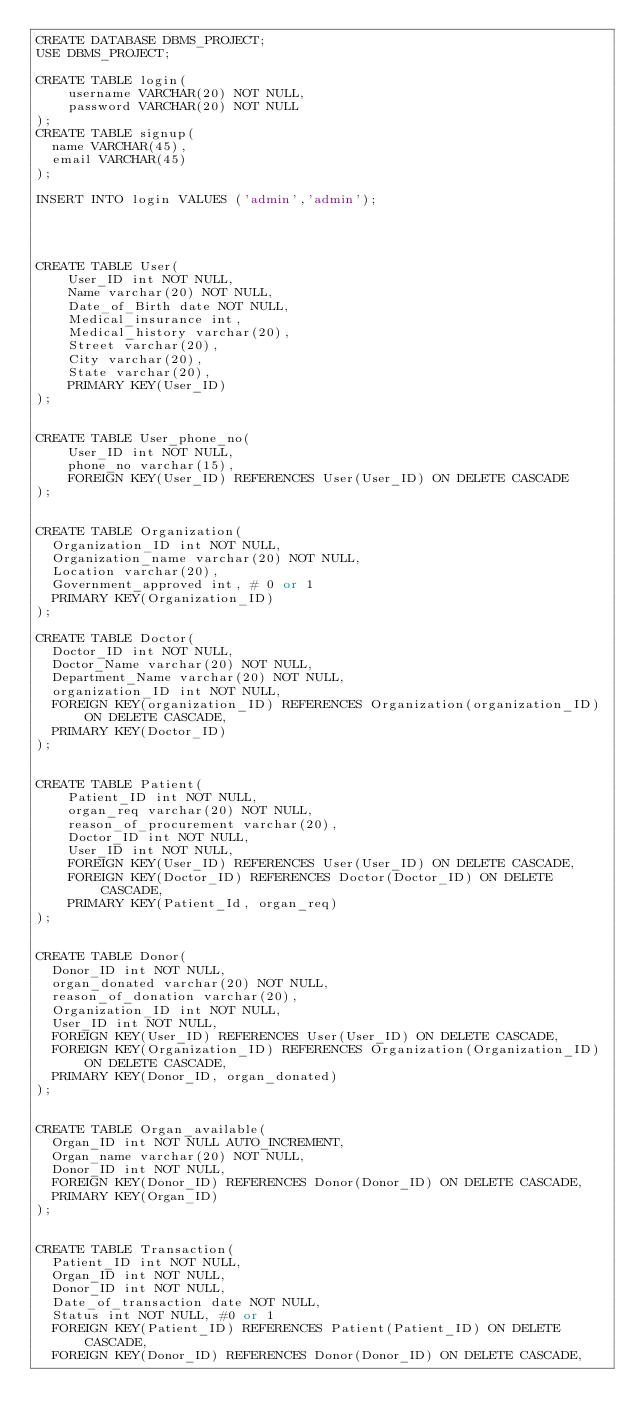Convert code to text. <code><loc_0><loc_0><loc_500><loc_500><_SQL_>CREATE DATABASE DBMS_PROJECT;
USE DBMS_PROJECT;

CREATE TABLE login(
    username VARCHAR(20) NOT NULL,
    password VARCHAR(20) NOT NULL
);
CREATE TABLE signup(
  name VARCHAR(45),
  email VARCHAR(45)
);

INSERT INTO login VALUES ('admin','admin');




CREATE TABLE User(
    User_ID int NOT NULL,
    Name varchar(20) NOT NULL,
    Date_of_Birth date NOT NULL,
    Medical_insurance int,
    Medical_history varchar(20),
    Street varchar(20),
    City varchar(20),
    State varchar(20),
    PRIMARY KEY(User_ID)
);


CREATE TABLE User_phone_no(
    User_ID int NOT NULL,
    phone_no varchar(15),
    FOREIGN KEY(User_ID) REFERENCES User(User_ID) ON DELETE CASCADE
);


CREATE TABLE Organization(
  Organization_ID int NOT NULL,
  Organization_name varchar(20) NOT NULL,
  Location varchar(20),
  Government_approved int, # 0 or 1
  PRIMARY KEY(Organization_ID)
);

CREATE TABLE Doctor(
  Doctor_ID int NOT NULL,
  Doctor_Name varchar(20) NOT NULL,
  Department_Name varchar(20) NOT NULL,
  organization_ID int NOT NULL,
  FOREIGN KEY(organization_ID) REFERENCES Organization(organization_ID) ON DELETE CASCADE,
  PRIMARY KEY(Doctor_ID)
);


CREATE TABLE Patient(
    Patient_ID int NOT NULL,
    organ_req varchar(20) NOT NULL,
    reason_of_procurement varchar(20),
    Doctor_ID int NOT NULL,
    User_ID int NOT NULL,
    FOREIGN KEY(User_ID) REFERENCES User(User_ID) ON DELETE CASCADE,
    FOREIGN KEY(Doctor_ID) REFERENCES Doctor(Doctor_ID) ON DELETE CASCADE,
    PRIMARY KEY(Patient_Id, organ_req)
);


CREATE TABLE Donor(
  Donor_ID int NOT NULL,
  organ_donated varchar(20) NOT NULL,
  reason_of_donation varchar(20),
  Organization_ID int NOT NULL,
  User_ID int NOT NULL,
  FOREIGN KEY(User_ID) REFERENCES User(User_ID) ON DELETE CASCADE,
  FOREIGN KEY(Organization_ID) REFERENCES Organization(Organization_ID) ON DELETE CASCADE,
  PRIMARY KEY(Donor_ID, organ_donated)
);


CREATE TABLE Organ_available(
  Organ_ID int NOT NULL AUTO_INCREMENT,
  Organ_name varchar(20) NOT NULL,
  Donor_ID int NOT NULL,
  FOREIGN KEY(Donor_ID) REFERENCES Donor(Donor_ID) ON DELETE CASCADE,
  PRIMARY KEY(Organ_ID)
);


CREATE TABLE Transaction(
  Patient_ID int NOT NULL,
  Organ_ID int NOT NULL,
  Donor_ID int NOT NULL,
  Date_of_transaction date NOT NULL,
  Status int NOT NULL, #0 or 1
  FOREIGN KEY(Patient_ID) REFERENCES Patient(Patient_ID) ON DELETE CASCADE,
  FOREIGN KEY(Donor_ID) REFERENCES Donor(Donor_ID) ON DELETE CASCADE,</code> 